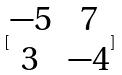<formula> <loc_0><loc_0><loc_500><loc_500>[ \begin{matrix} - 5 & 7 \\ 3 & - 4 \end{matrix} ]</formula> 